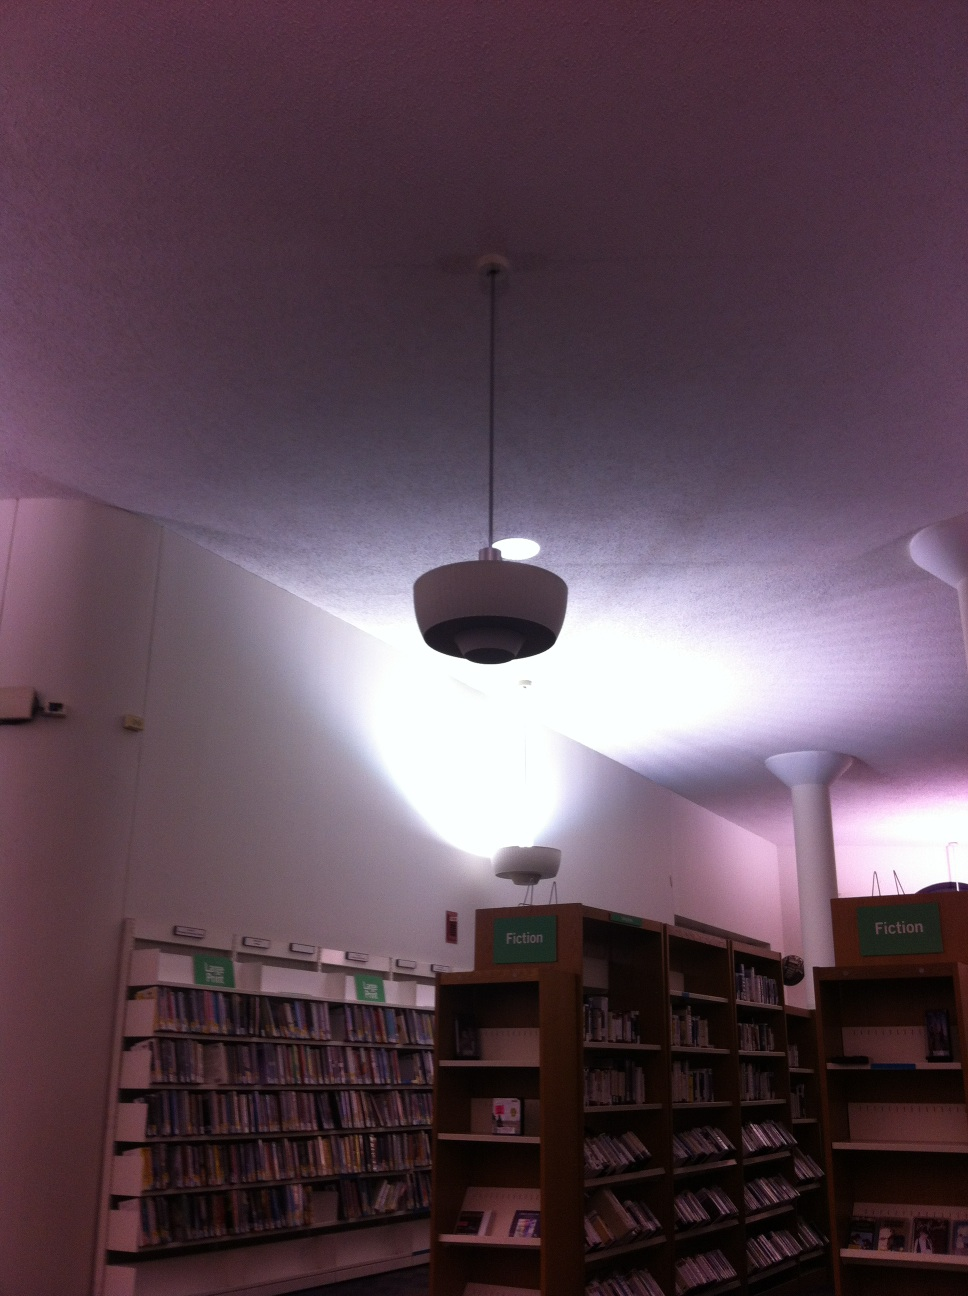If this library were turned into a community space, what events could take place here? As a community space, this library could host a variety of events including book clubs, author meet-and-greets, writing workshops, children's storytime, and educational seminars. There could also be cultural events like art exhibits, poetry readings, and music concerts, making it a vibrant and inclusive hub for community engagement. I need a quiet place to study. Is this library a good venue for that? Yes, this library is an excellent place for studying. It is designed to offer a quiet and peaceful environment, ideal for focusing on your work. There are designated study areas and ample seating to ensure you have a comfortable space to concentrate. 